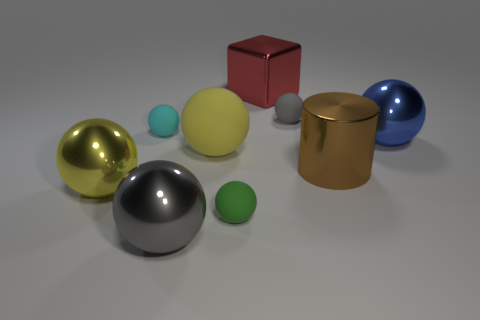Subtract all cyan balls. How many balls are left? 6 Subtract all tiny matte spheres. How many spheres are left? 4 Subtract 4 balls. How many balls are left? 3 Subtract all yellow spheres. Subtract all gray blocks. How many spheres are left? 5 Add 1 blue rubber balls. How many objects exist? 10 Subtract all blocks. How many objects are left? 8 Add 8 small gray balls. How many small gray balls exist? 9 Subtract 0 brown cubes. How many objects are left? 9 Subtract all yellow metallic balls. Subtract all small objects. How many objects are left? 5 Add 6 big brown shiny cylinders. How many big brown shiny cylinders are left? 7 